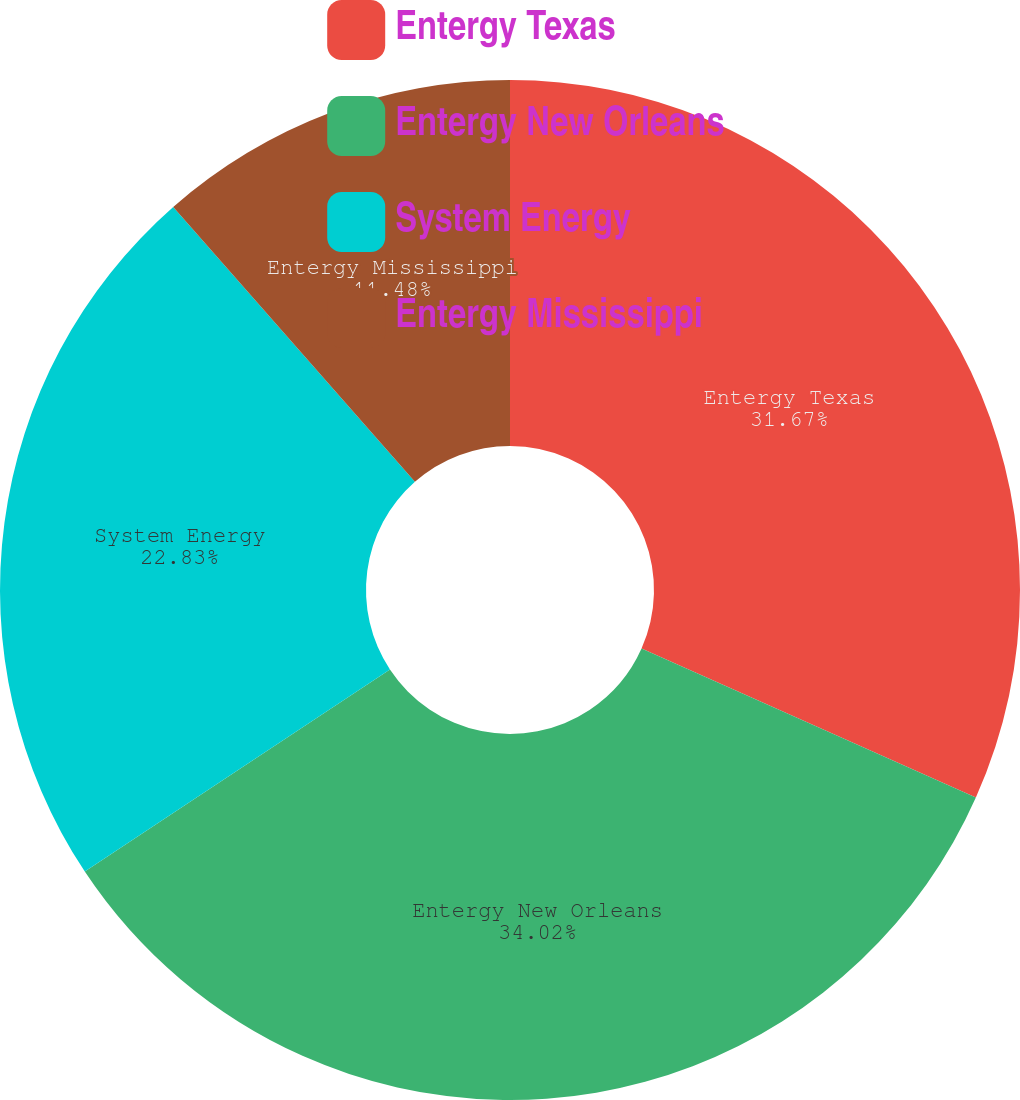Convert chart. <chart><loc_0><loc_0><loc_500><loc_500><pie_chart><fcel>Entergy Texas<fcel>Entergy New Orleans<fcel>System Energy<fcel>Entergy Mississippi<nl><fcel>31.67%<fcel>34.02%<fcel>22.83%<fcel>11.48%<nl></chart> 